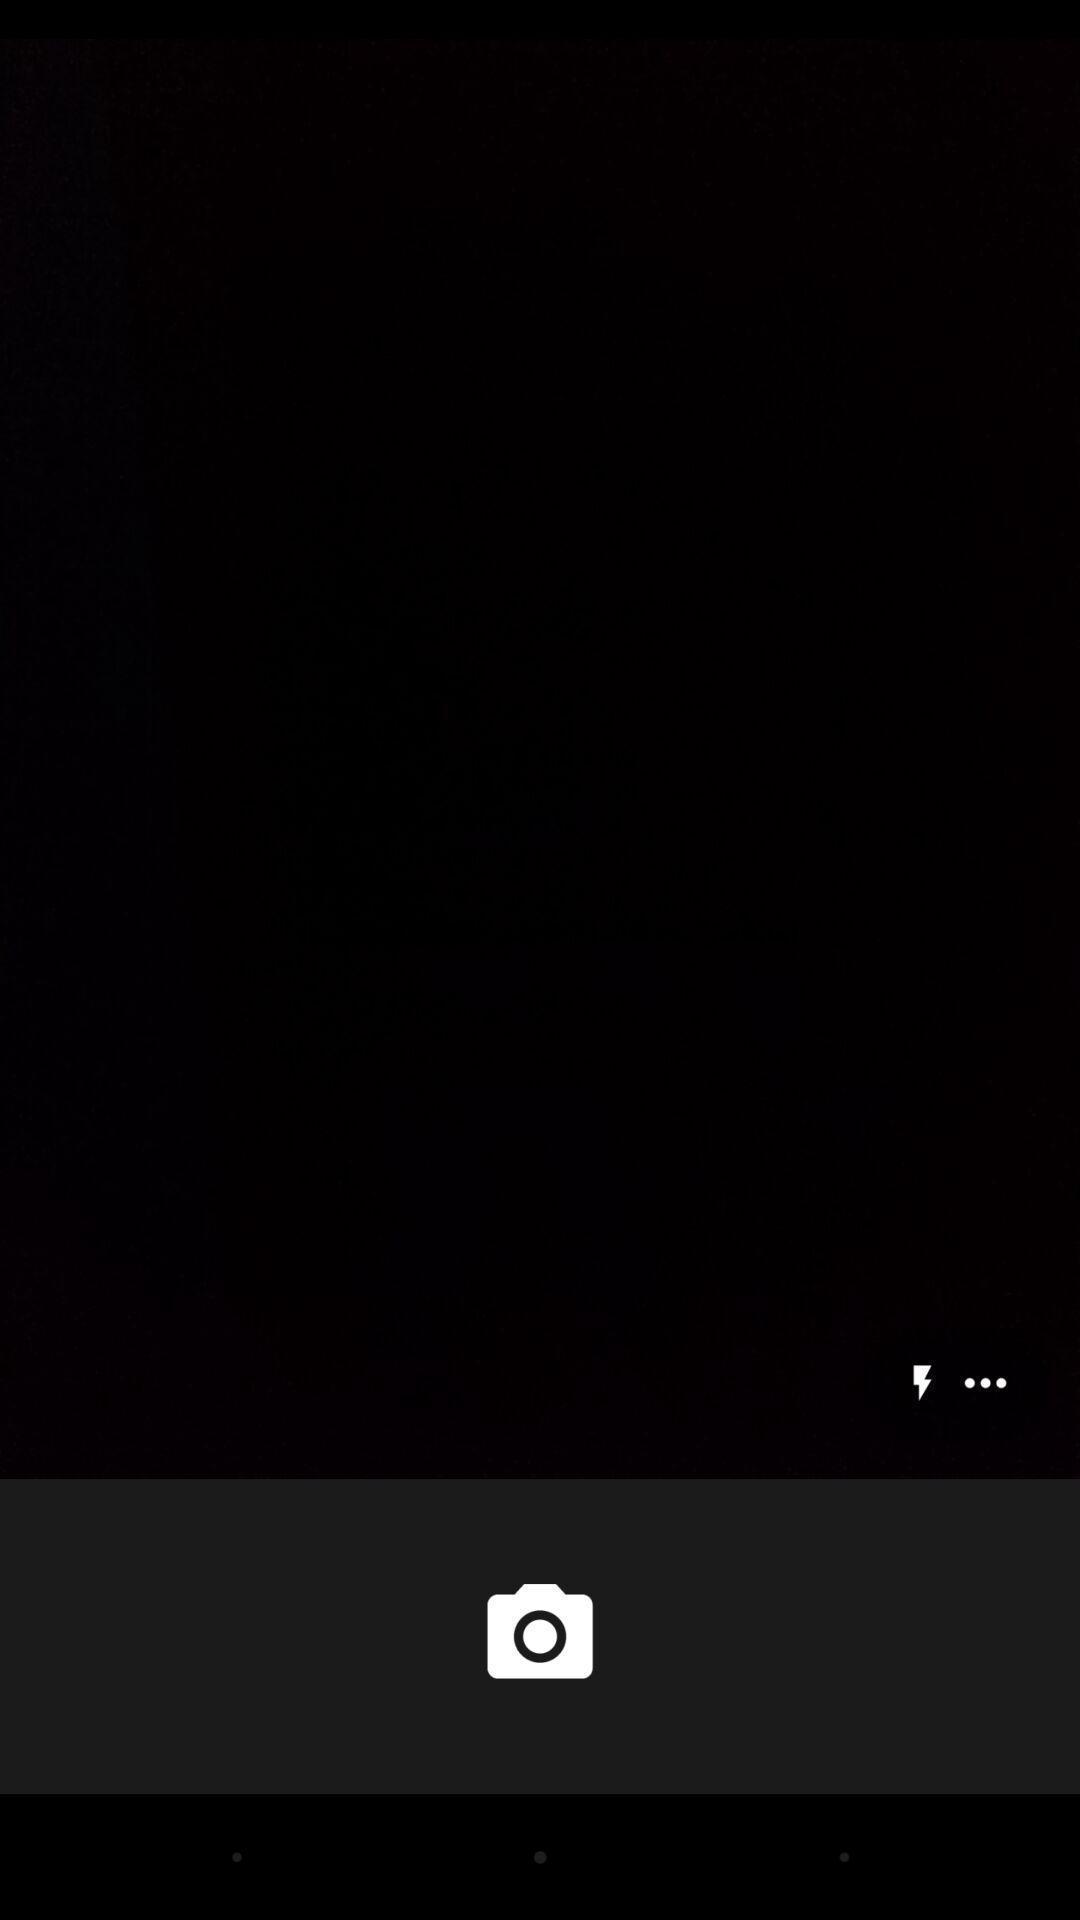Summarize the main components in this picture. Screen shows blank with camera icon. 